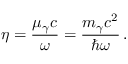<formula> <loc_0><loc_0><loc_500><loc_500>\eta = \frac { \mu _ { \gamma } c } { \omega } = \frac { m _ { \gamma } c ^ { 2 } } { \hbar { \omega } } \, .</formula> 